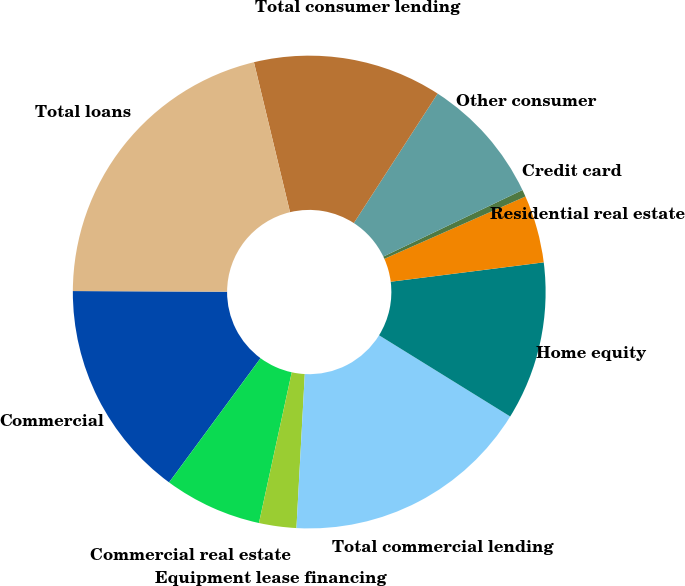Convert chart. <chart><loc_0><loc_0><loc_500><loc_500><pie_chart><fcel>Commercial<fcel>Commercial real estate<fcel>Equipment lease financing<fcel>Total commercial lending<fcel>Home equity<fcel>Residential real estate<fcel>Credit card<fcel>Other consumer<fcel>Total consumer lending<fcel>Total loans<nl><fcel>14.97%<fcel>6.69%<fcel>2.55%<fcel>17.04%<fcel>10.83%<fcel>4.62%<fcel>0.48%<fcel>8.76%<fcel>12.9%<fcel>21.18%<nl></chart> 